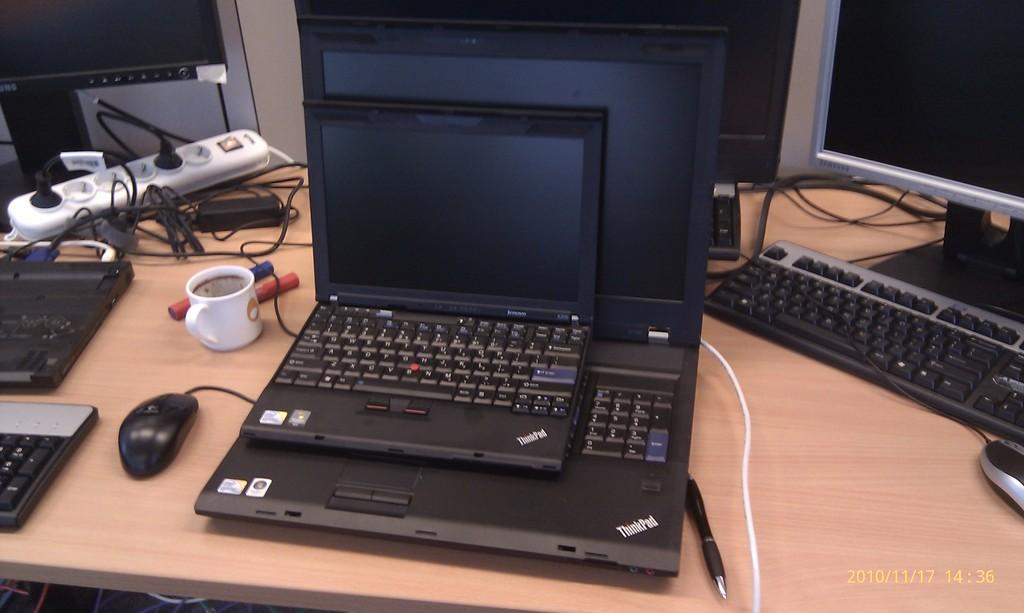<image>
Provide a brief description of the given image. A small ThinkPad laptop is sitting on top of a larger ThinkPad laptop. 